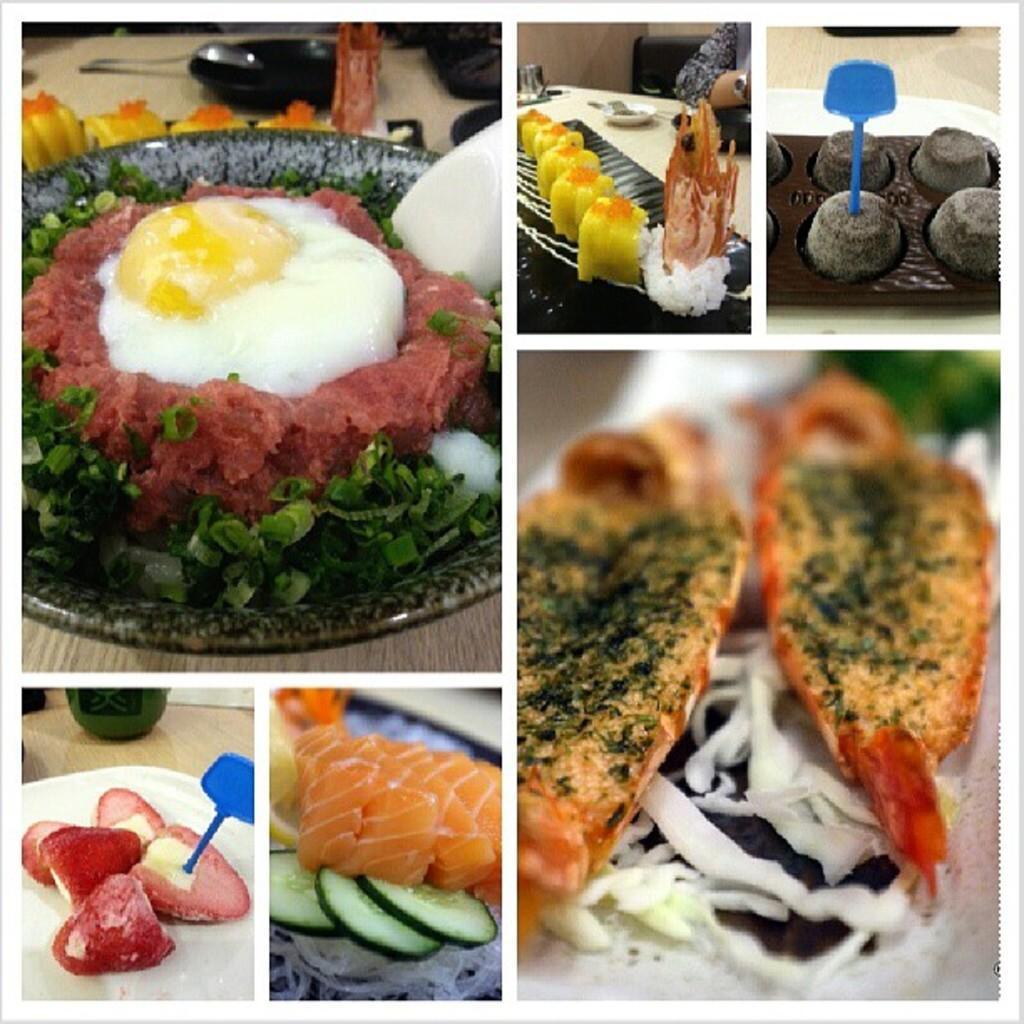Could you give a brief overview of what you see in this image? This is an edited image. This picture is the college of six images. In each image, we see a plate containing the food items is placed on the table. These food items are in white, red, green, yellow, brown and orange color. In the left top, we see a plate and a spoon are placed on the table. 